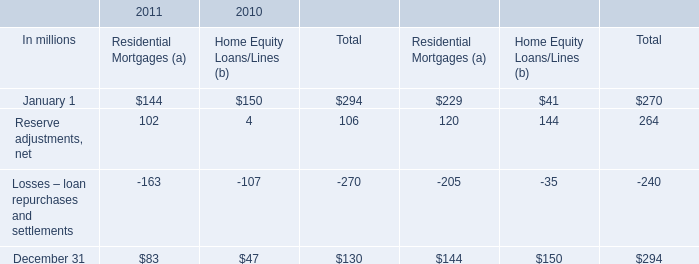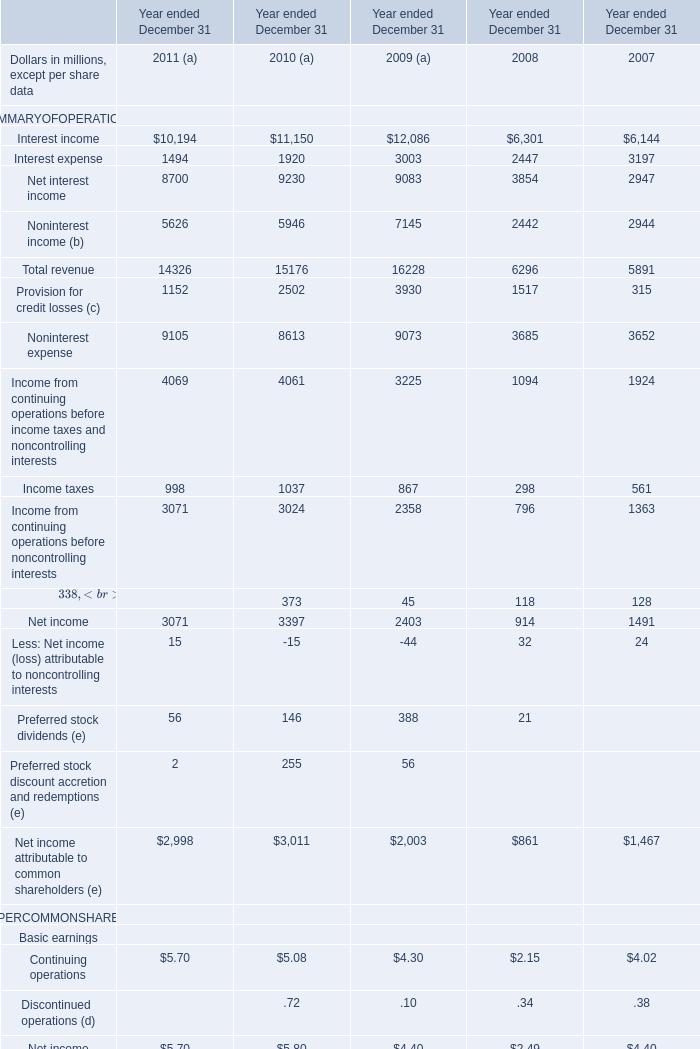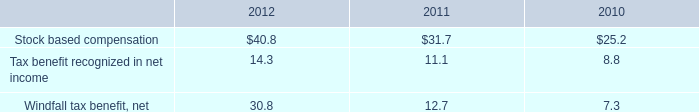What is the sum of Noninterest income (b) in the range of 1 and 100000 in 2011 and 2010 ? (in million) 
Computations: (5626 + 5946)
Answer: 11572.0. 